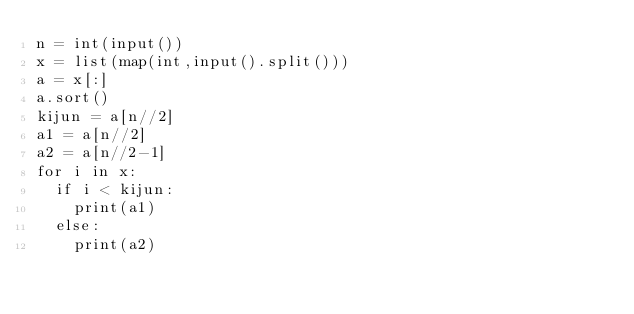Convert code to text. <code><loc_0><loc_0><loc_500><loc_500><_Python_>n = int(input())
x = list(map(int,input().split()))
a = x[:]
a.sort()
kijun = a[n//2]
a1 = a[n//2]
a2 = a[n//2-1]
for i in x:
	if i < kijun:
		print(a1)
	else:
		print(a2)</code> 